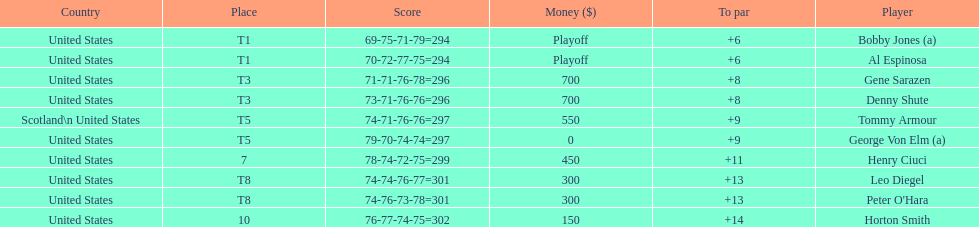Which two players tied for first place? Bobby Jones (a), Al Espinosa. 